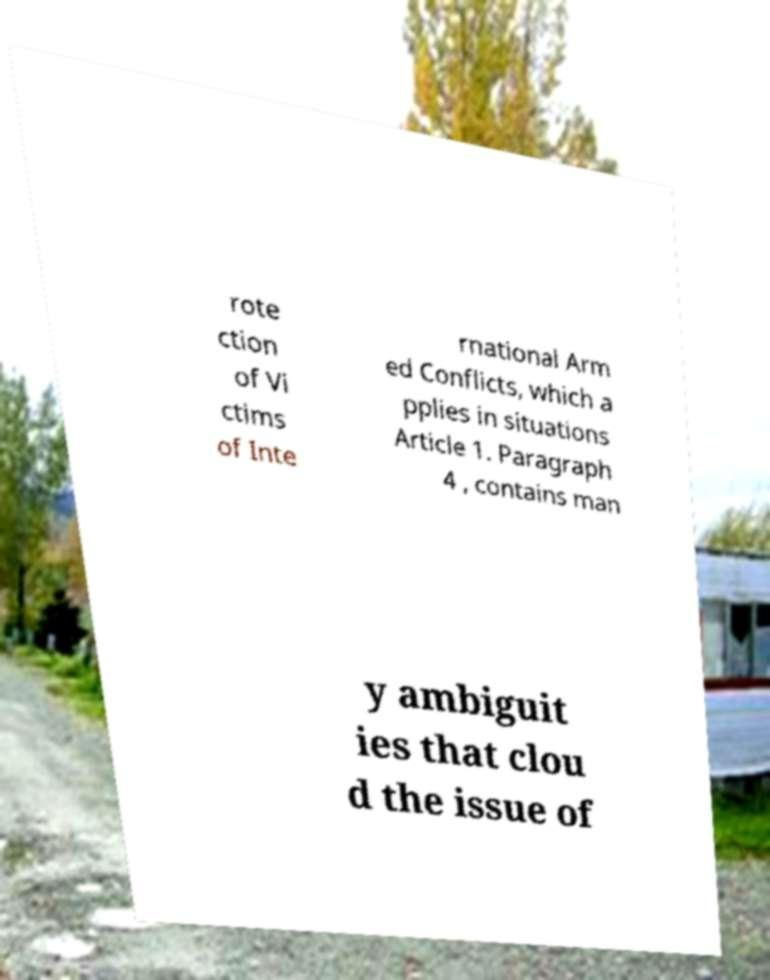What messages or text are displayed in this image? I need them in a readable, typed format. rote ction of Vi ctims of Inte rnational Arm ed Conflicts, which a pplies in situations Article 1. Paragraph 4 , contains man y ambiguit ies that clou d the issue of 